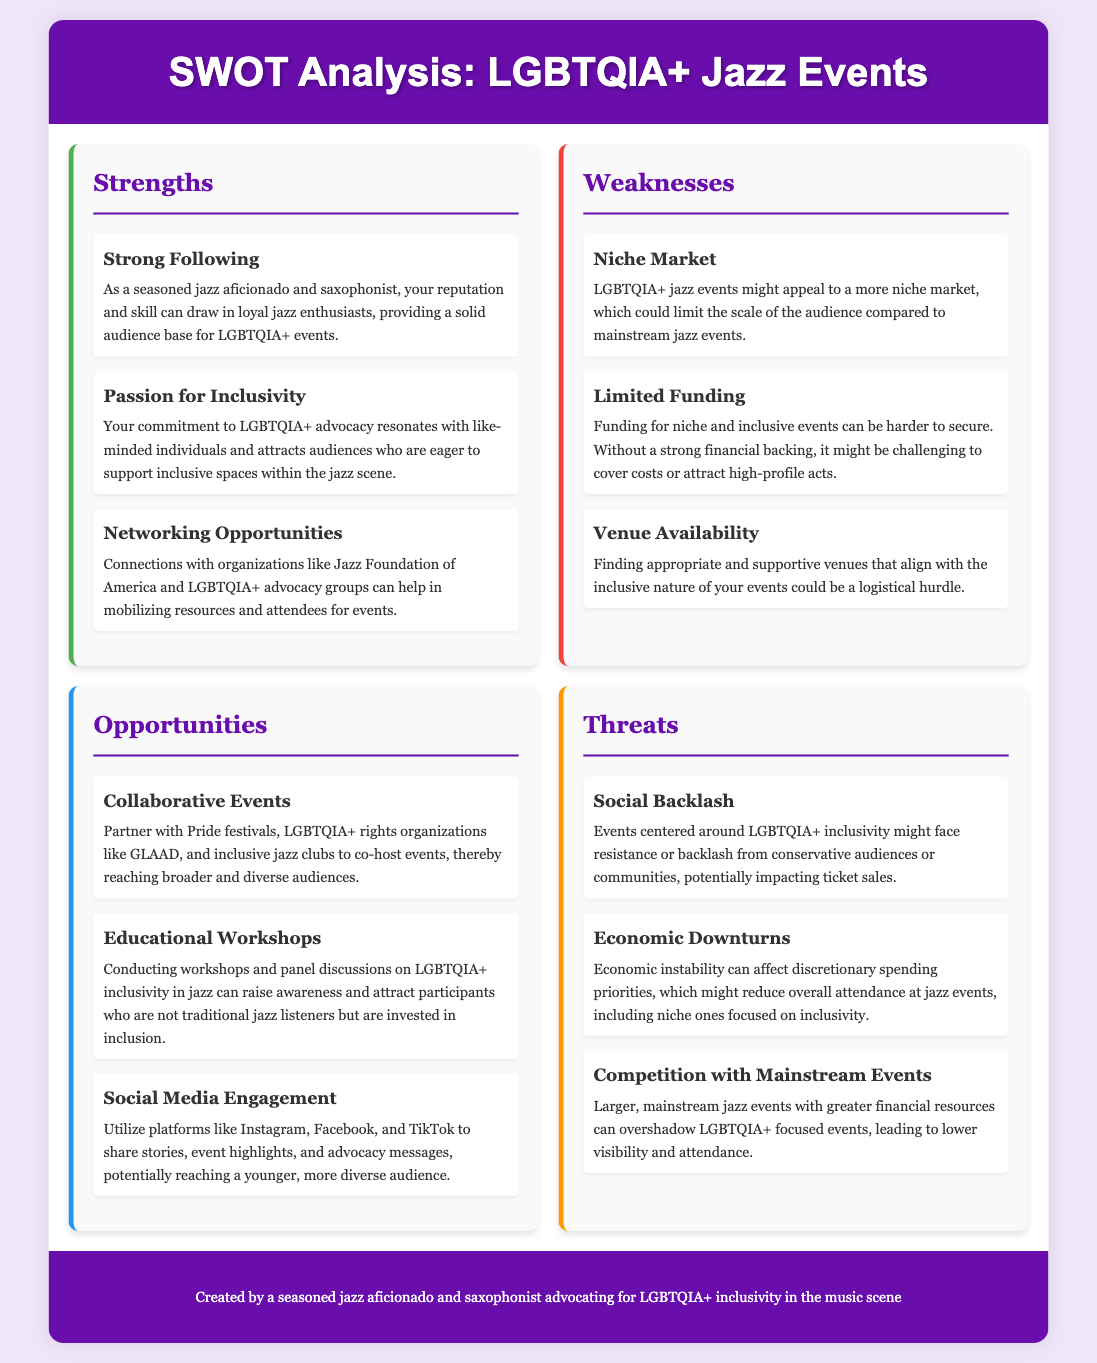what is the title of the document? The title of the document is mentioned in the header of the rendered HTML as "SWOT Analysis: LGBTQIA+ Jazz Events."
Answer: SWOT Analysis: LGBTQIA+ Jazz Events how many strengths are listed? The document includes three items under the Strengths section.
Answer: 3 what is one weakness mentioned? The document outlines several weaknesses, including "Niche Market."
Answer: Niche Market name an opportunity for LGBTQIA+ jazz events. One opportunity listed in the document is "Collaborative Events."
Answer: Collaborative Events what color is used for the strengths section? The strength section is marked with a green left border.
Answer: green what threat is associated with economic conditions? The document mentions "Economic Downturns" as a threat related to economic conditions.
Answer: Economic Downturns who can be partnered with for collaborative events? The document suggests partnering with "Pride festivals" for collaborative events.
Answer: Pride festivals how many opportunities are identified? There are three opportunities outlined in the Opportunities section of the document.
Answer: 3 what organization is mentioned as a networking opportunity? The document refers to the "Jazz Foundation of America" as a networking opportunity.
Answer: Jazz Foundation of America 